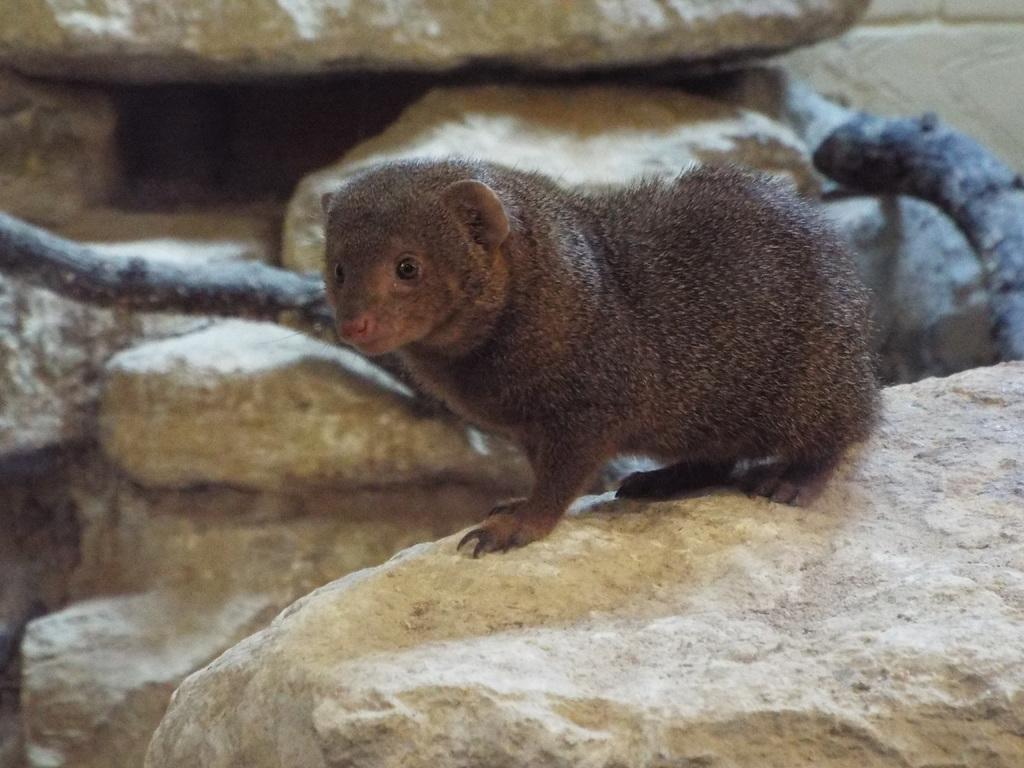What animal is the main subject of the image? There is a mongoose in the image. What can be seen in the background of the image? There are rocks, sticks, and other objects in the background of the image. Can you describe the rock at the bottom of the image? Yes, there is a rock at the bottom of the image. What suggestion does the cow make to the mongoose in the image? There is no cow present in the image, so it is not possible to answer that question. 